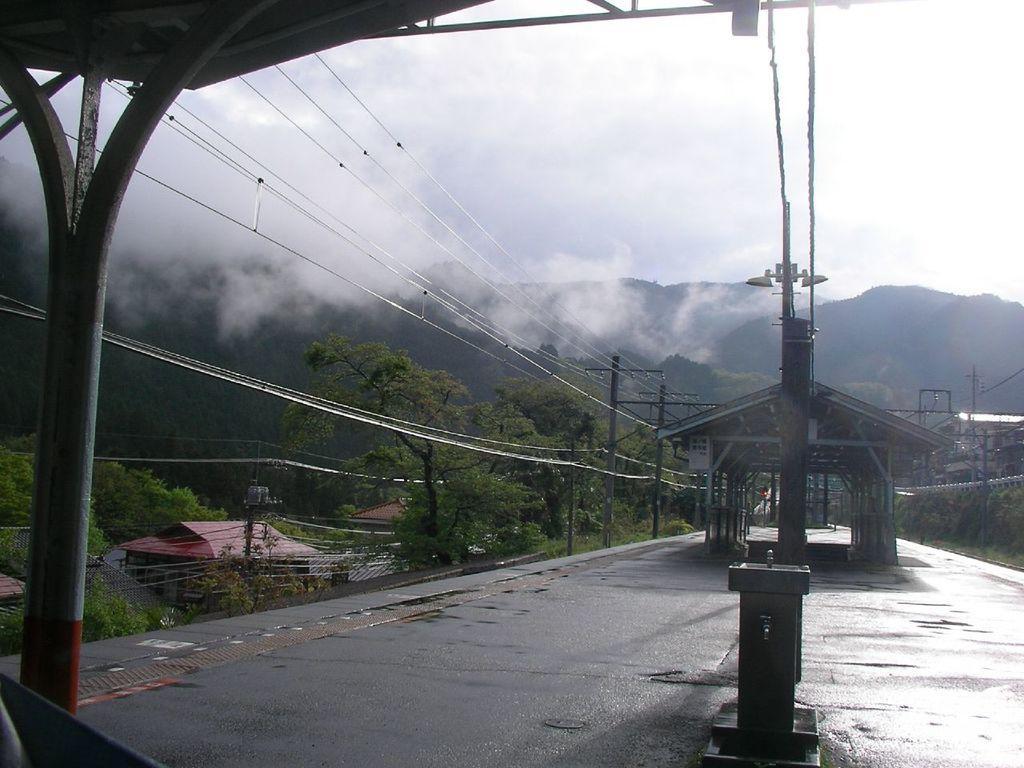Please provide a concise description of this image. On the left side of the image we can see one pole and the roof. In the background, we can see the sky, clouds, hills, trees, smoke, poles, wires, buildings, grass and a few other objects. 